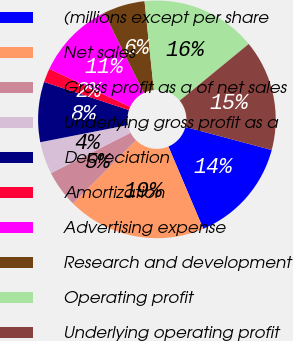Convert chart. <chart><loc_0><loc_0><loc_500><loc_500><pie_chart><fcel>(millions except per share<fcel>Net sales<fcel>Gross profit as a of net sales<fcel>Underlying gross profit as a<fcel>Depreciation<fcel>Amortization<fcel>Advertising expense<fcel>Research and development<fcel>Operating profit<fcel>Underlying operating profit<nl><fcel>14.47%<fcel>18.87%<fcel>5.03%<fcel>4.4%<fcel>8.18%<fcel>1.89%<fcel>10.69%<fcel>5.66%<fcel>15.72%<fcel>15.09%<nl></chart> 